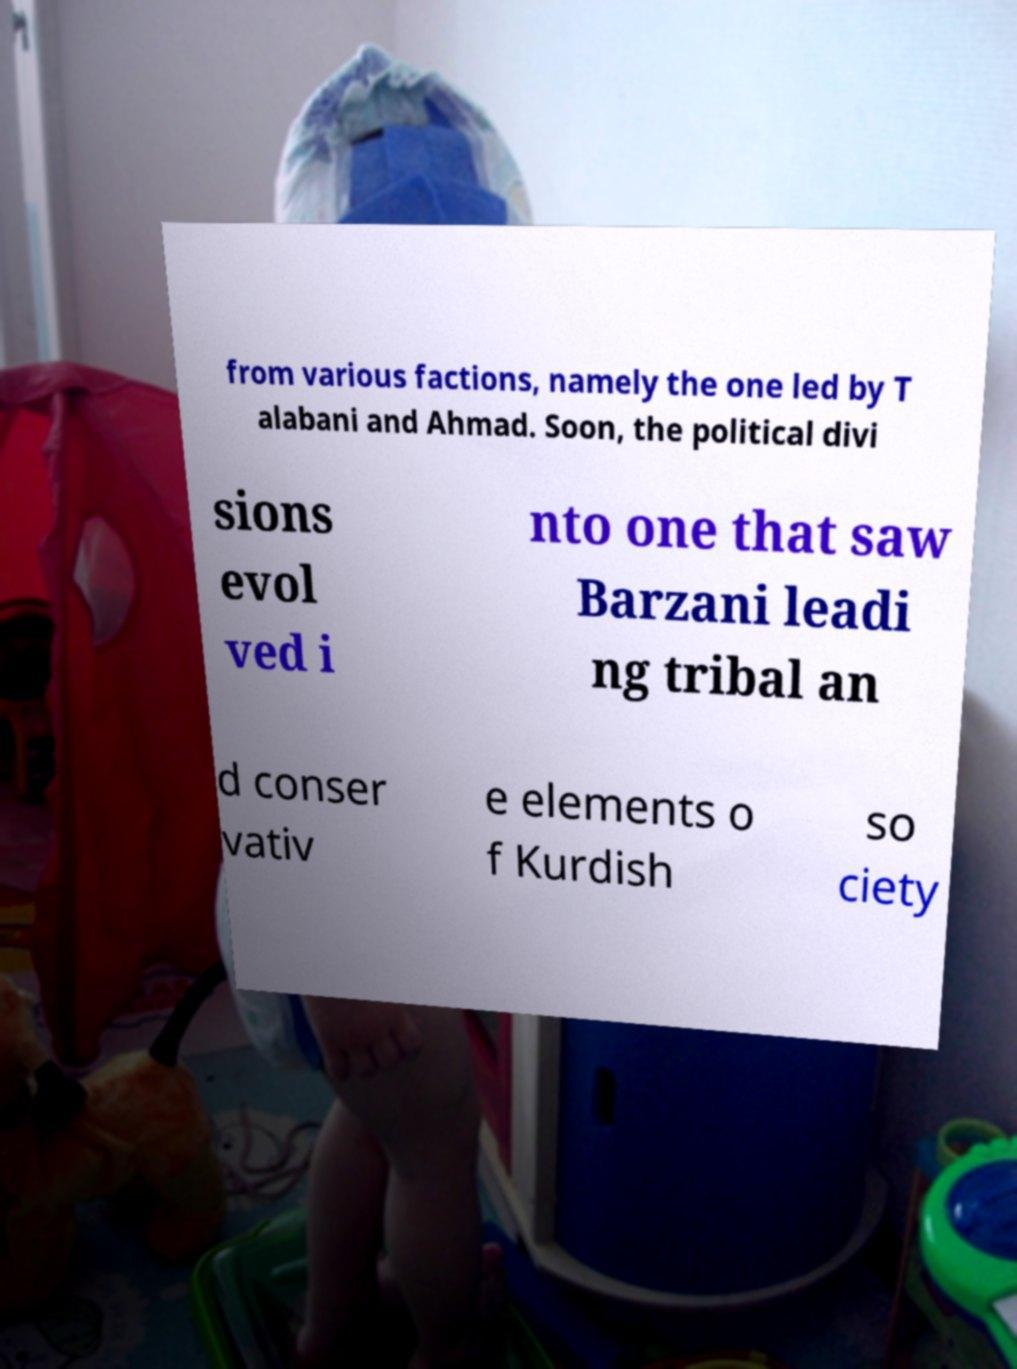There's text embedded in this image that I need extracted. Can you transcribe it verbatim? from various factions, namely the one led by T alabani and Ahmad. Soon, the political divi sions evol ved i nto one that saw Barzani leadi ng tribal an d conser vativ e elements o f Kurdish so ciety 